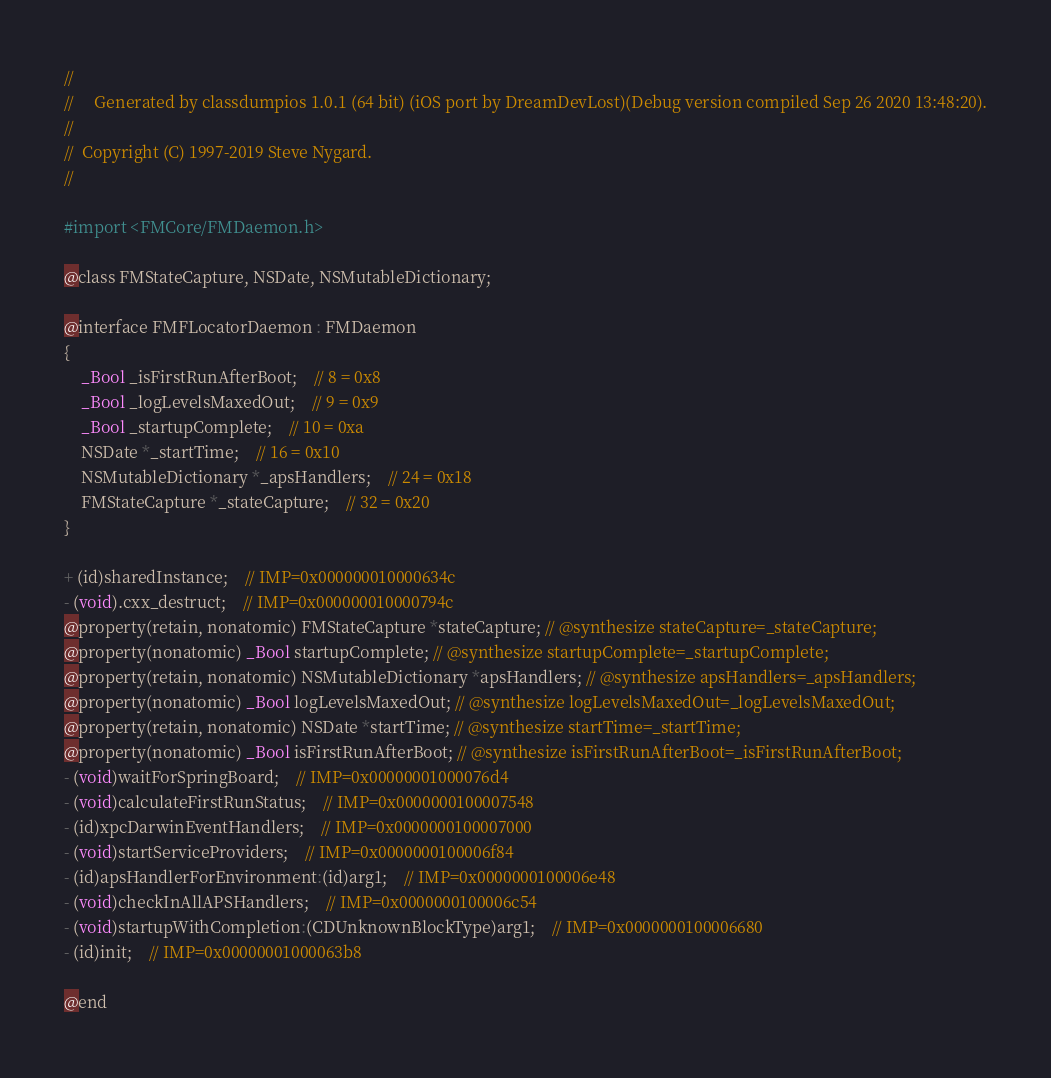<code> <loc_0><loc_0><loc_500><loc_500><_C_>//
//     Generated by classdumpios 1.0.1 (64 bit) (iOS port by DreamDevLost)(Debug version compiled Sep 26 2020 13:48:20).
//
//  Copyright (C) 1997-2019 Steve Nygard.
//

#import <FMCore/FMDaemon.h>

@class FMStateCapture, NSDate, NSMutableDictionary;

@interface FMFLocatorDaemon : FMDaemon
{
    _Bool _isFirstRunAfterBoot;	// 8 = 0x8
    _Bool _logLevelsMaxedOut;	// 9 = 0x9
    _Bool _startupComplete;	// 10 = 0xa
    NSDate *_startTime;	// 16 = 0x10
    NSMutableDictionary *_apsHandlers;	// 24 = 0x18
    FMStateCapture *_stateCapture;	// 32 = 0x20
}

+ (id)sharedInstance;	// IMP=0x000000010000634c
- (void).cxx_destruct;	// IMP=0x000000010000794c
@property(retain, nonatomic) FMStateCapture *stateCapture; // @synthesize stateCapture=_stateCapture;
@property(nonatomic) _Bool startupComplete; // @synthesize startupComplete=_startupComplete;
@property(retain, nonatomic) NSMutableDictionary *apsHandlers; // @synthesize apsHandlers=_apsHandlers;
@property(nonatomic) _Bool logLevelsMaxedOut; // @synthesize logLevelsMaxedOut=_logLevelsMaxedOut;
@property(retain, nonatomic) NSDate *startTime; // @synthesize startTime=_startTime;
@property(nonatomic) _Bool isFirstRunAfterBoot; // @synthesize isFirstRunAfterBoot=_isFirstRunAfterBoot;
- (void)waitForSpringBoard;	// IMP=0x00000001000076d4
- (void)calculateFirstRunStatus;	// IMP=0x0000000100007548
- (id)xpcDarwinEventHandlers;	// IMP=0x0000000100007000
- (void)startServiceProviders;	// IMP=0x0000000100006f84
- (id)apsHandlerForEnvironment:(id)arg1;	// IMP=0x0000000100006e48
- (void)checkInAllAPSHandlers;	// IMP=0x0000000100006c54
- (void)startupWithCompletion:(CDUnknownBlockType)arg1;	// IMP=0x0000000100006680
- (id)init;	// IMP=0x00000001000063b8

@end

</code> 